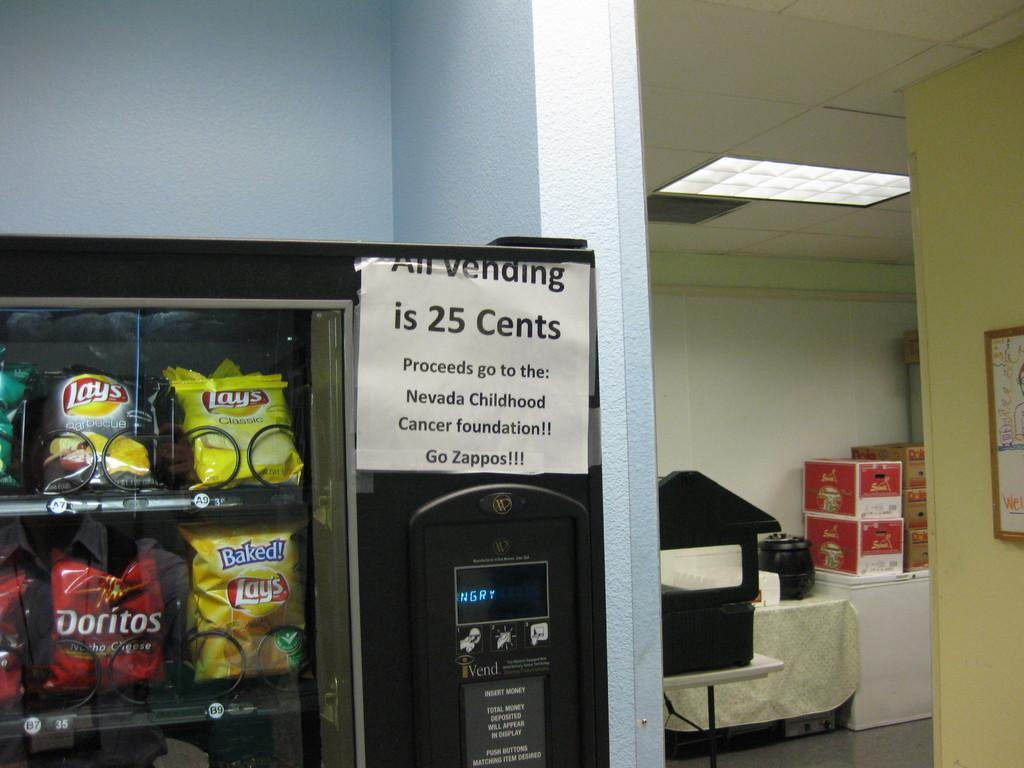<image>
Describe the image concisely. A vending machine with a sign stating all vending is a quarter. 